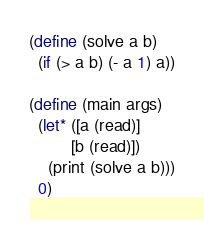<code> <loc_0><loc_0><loc_500><loc_500><_Scheme_>(define (solve a b)
  (if (> a b) (- a 1) a))

(define (main args)
  (let* ([a (read)]
         [b (read)])
    (print (solve a b)))
  0)
</code> 